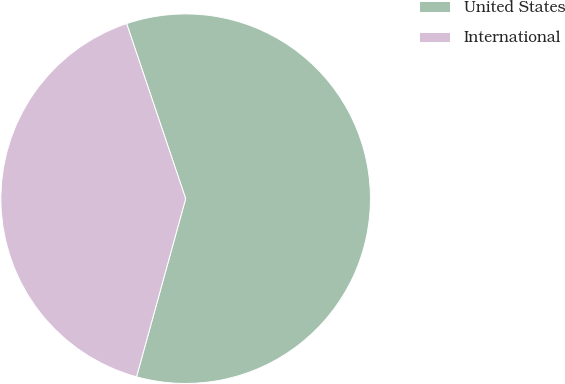Convert chart to OTSL. <chart><loc_0><loc_0><loc_500><loc_500><pie_chart><fcel>United States<fcel>International<nl><fcel>59.46%<fcel>40.54%<nl></chart> 